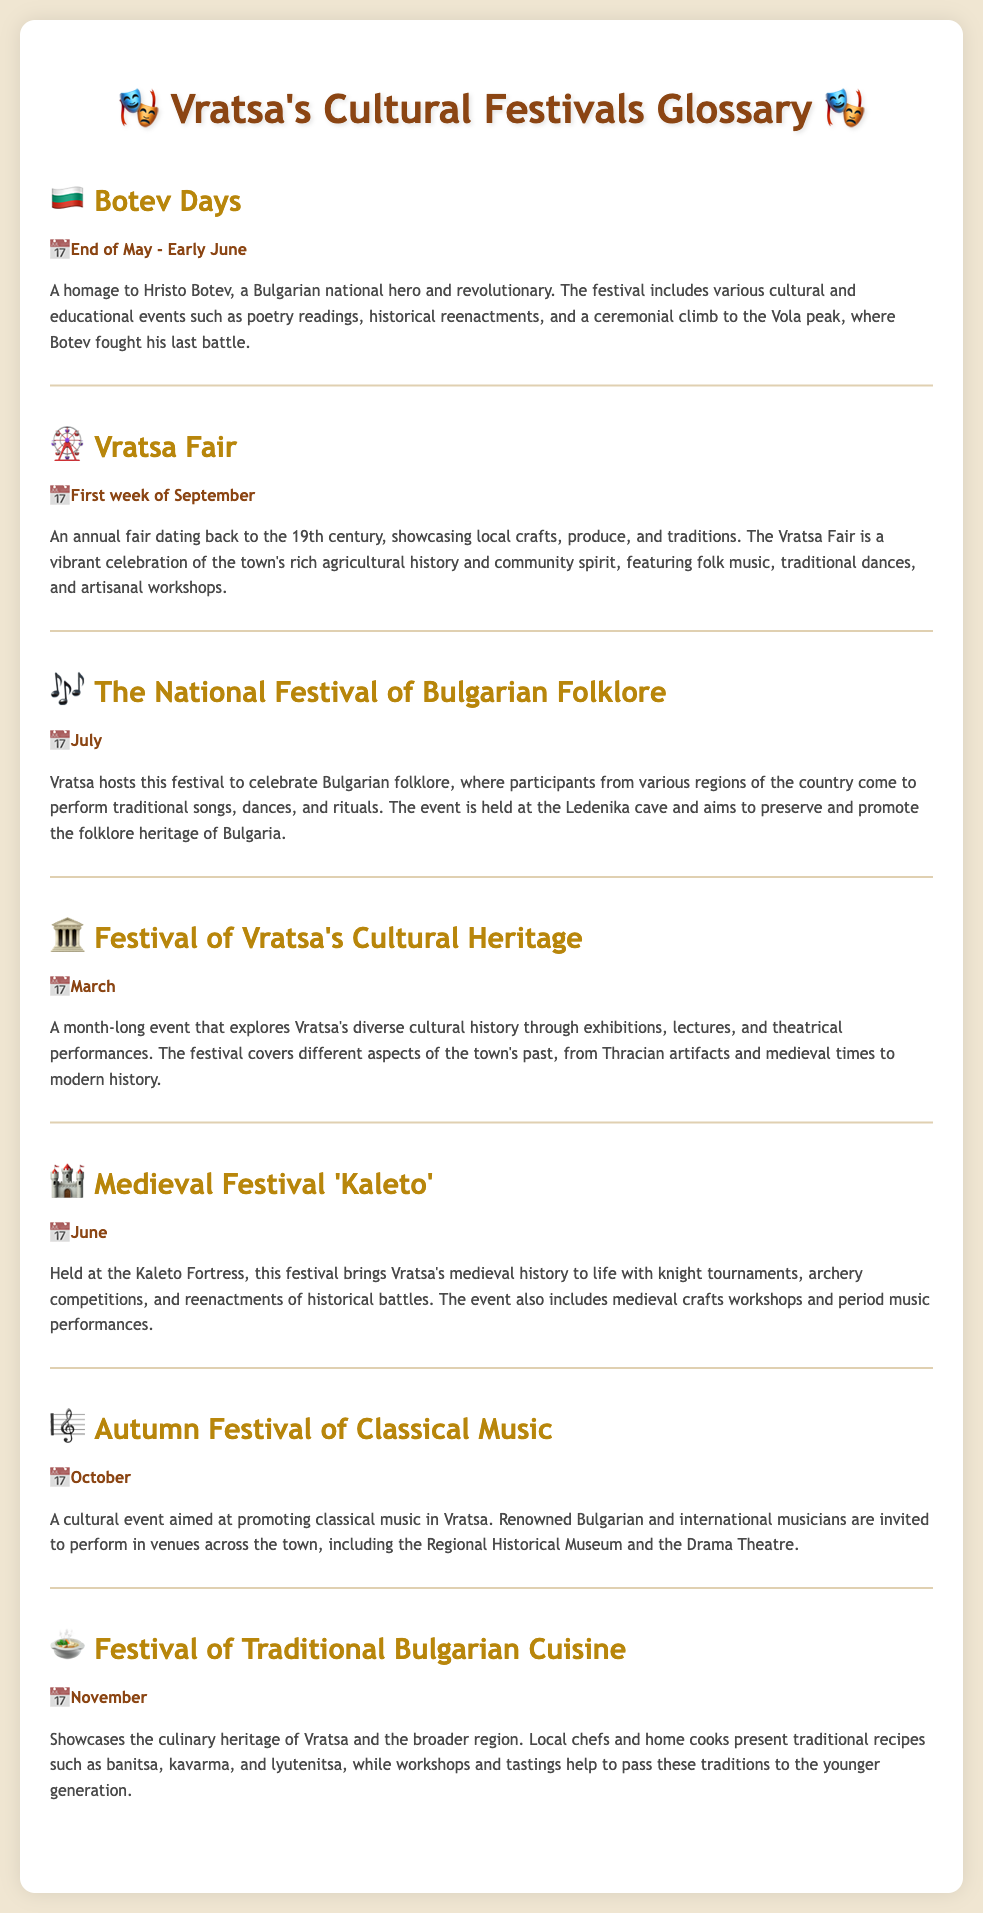What is the name of the Bulgarian national hero commemorated during the Botev Days? The Botev Days festival is a homage to Hristo Botev, a Bulgarian national hero.
Answer: Hristo Botev When do the Botev Days take place? The document states that the Botev Days occur at the end of May to early June.
Answer: End of May - Early June What is the main theme of the Festival of Vratsa's Cultural Heritage? The Festival explores Vratsa's diverse cultural history through exhibitions, lectures, and theatrical performances.
Answer: Cultural history In which month is the Autumn Festival of Classical Music held? According to the document, the Autumn Festival of Classical Music takes place in October.
Answer: October What type of events are included in the Medieval Festival 'Kaleto'? The Medieval Festival 'Kaleto' includes knight tournaments, archery competitions, and reenactments of historical battles.
Answer: Knight tournaments How long does the Festival of Vratsa's Cultural Heritage last? The document specifies it is a month-long event.
Answer: Month-long What event takes place in July? The document mentions The National Festival of Bulgarian Folklore takes place in July.
Answer: The National Festival of Bulgarian Folklore Which festival is associated with traditional Bulgarian cuisine? The Festival of Traditional Bulgarian Cuisine is focused on showcasing culinary heritage.
Answer: Festival of Traditional Bulgarian Cuisine 